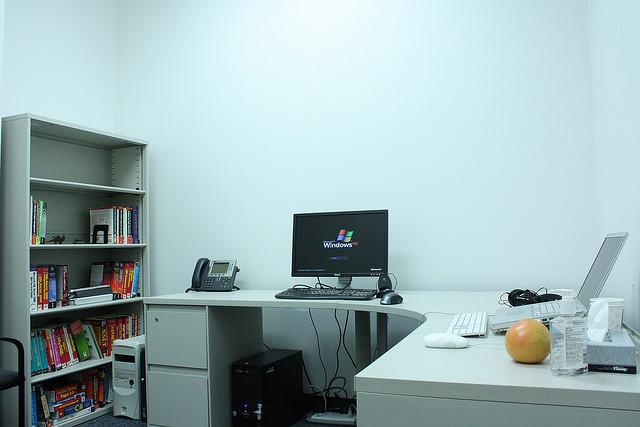What general subject do the books in the bookcase to the left of the phone cover? information technology 